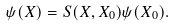<formula> <loc_0><loc_0><loc_500><loc_500>\psi ( X ) = S ( X , X _ { 0 } ) \psi ( X _ { 0 } ) .</formula> 